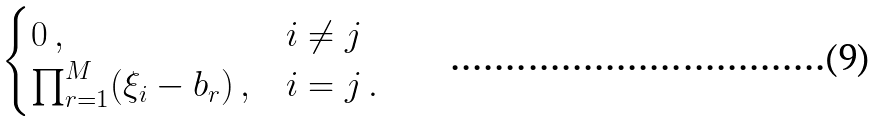<formula> <loc_0><loc_0><loc_500><loc_500>\begin{cases} 0 \, , & i \neq j \\ \prod _ { r = 1 } ^ { M } ( \xi _ { i } - b _ { r } ) \, , & i = j \, . \end{cases}</formula> 